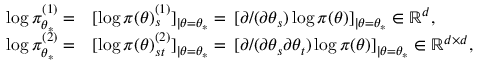<formula> <loc_0><loc_0><loc_500><loc_500>\begin{array} { r } { \begin{array} { r l } { \log \pi _ { \theta _ { * } } ^ { ( 1 ) } = } & { [ \log \pi ( \theta ) _ { s } ^ { ( 1 ) } ] _ { | \theta = \theta _ { * } } = \, [ \partial / ( \partial \theta _ { s } ) \log \pi ( \theta ) ] _ { | \theta = \theta _ { * } } \in \mathbb { R } ^ { d } , } \\ { \log \pi _ { \theta _ { * } } ^ { ( 2 ) } = } & { [ \log \pi ( \theta ) _ { s t } ^ { ( 2 ) } ] _ { | \theta = \theta _ { * } } = \, [ \partial / ( \partial \theta _ { s } \partial \theta _ { t } ) \log \pi ( \theta ) ] _ { | \theta = \theta _ { * } } \in \mathbb { R } ^ { d \times d } , } \end{array} } \end{array}</formula> 